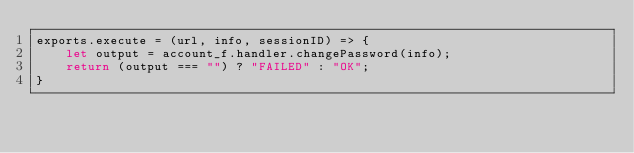<code> <loc_0><loc_0><loc_500><loc_500><_JavaScript_>exports.execute = (url, info, sessionID) => {
	let output = account_f.handler.changePassword(info);
    return (output === "") ? "FAILED" : "OK";
}</code> 